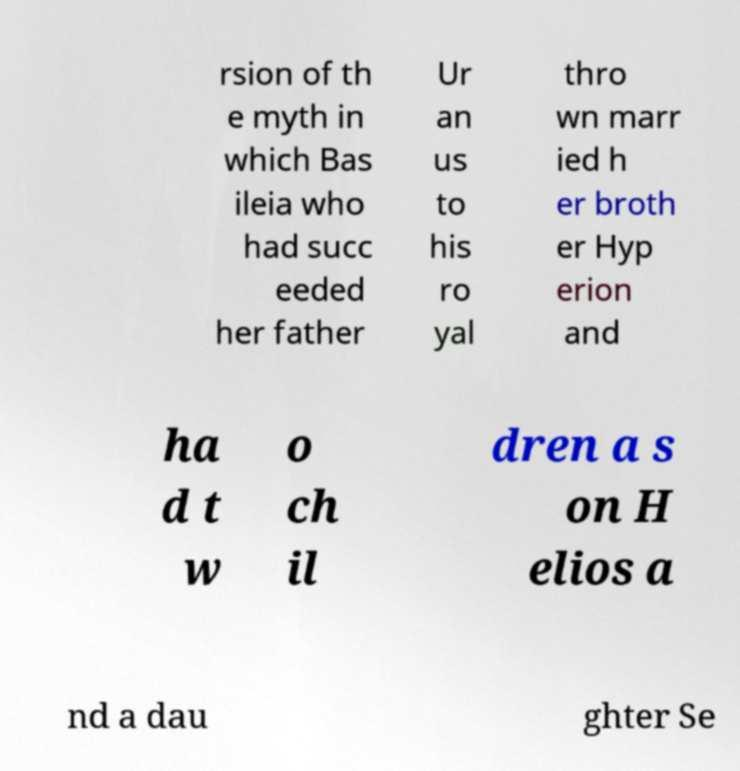What messages or text are displayed in this image? I need them in a readable, typed format. rsion of th e myth in which Bas ileia who had succ eeded her father Ur an us to his ro yal thro wn marr ied h er broth er Hyp erion and ha d t w o ch il dren a s on H elios a nd a dau ghter Se 